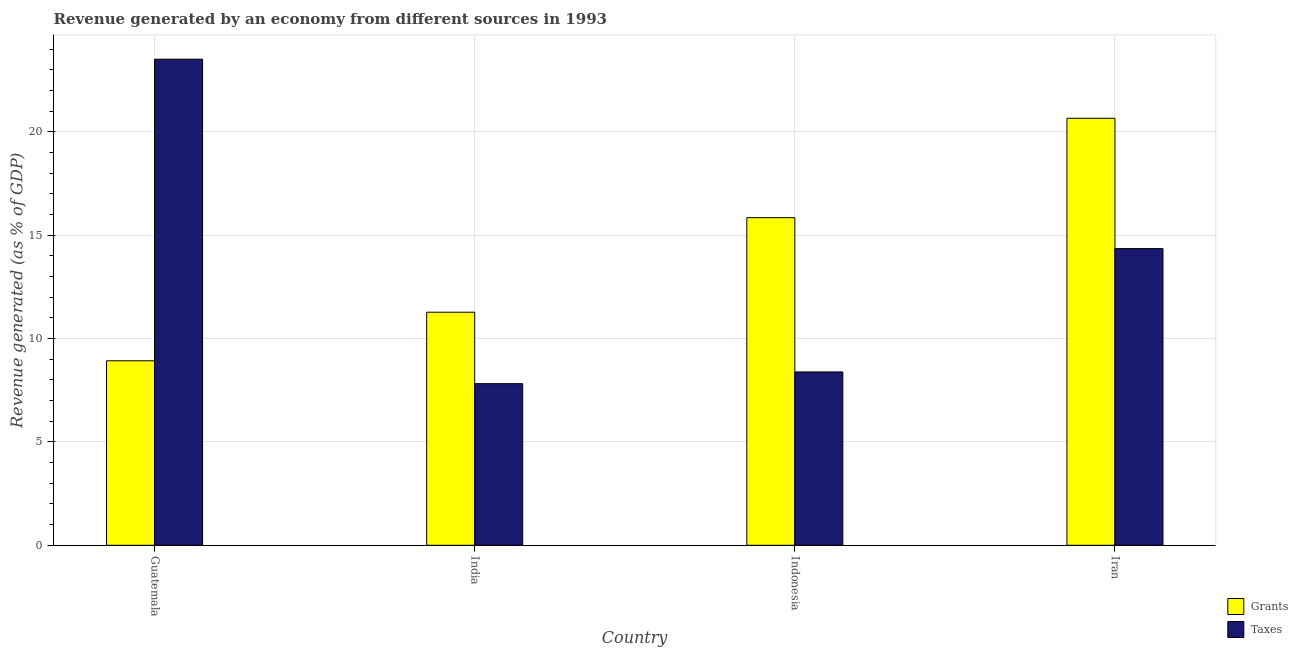How many groups of bars are there?
Offer a terse response. 4. Are the number of bars per tick equal to the number of legend labels?
Give a very brief answer. Yes. Are the number of bars on each tick of the X-axis equal?
Your answer should be very brief. Yes. How many bars are there on the 1st tick from the left?
Provide a short and direct response. 2. How many bars are there on the 4th tick from the right?
Ensure brevity in your answer.  2. What is the revenue generated by taxes in Guatemala?
Provide a short and direct response. 23.52. Across all countries, what is the maximum revenue generated by taxes?
Keep it short and to the point. 23.52. Across all countries, what is the minimum revenue generated by taxes?
Offer a very short reply. 7.82. In which country was the revenue generated by taxes maximum?
Your response must be concise. Guatemala. In which country was the revenue generated by grants minimum?
Give a very brief answer. Guatemala. What is the total revenue generated by taxes in the graph?
Make the answer very short. 54.09. What is the difference between the revenue generated by taxes in India and that in Indonesia?
Give a very brief answer. -0.57. What is the difference between the revenue generated by grants in Iran and the revenue generated by taxes in Guatemala?
Provide a succinct answer. -2.86. What is the average revenue generated by grants per country?
Your answer should be compact. 14.18. What is the difference between the revenue generated by grants and revenue generated by taxes in Iran?
Provide a short and direct response. 6.31. In how many countries, is the revenue generated by taxes greater than 9 %?
Offer a very short reply. 2. What is the ratio of the revenue generated by grants in Guatemala to that in India?
Ensure brevity in your answer.  0.79. Is the difference between the revenue generated by taxes in India and Iran greater than the difference between the revenue generated by grants in India and Iran?
Make the answer very short. Yes. What is the difference between the highest and the second highest revenue generated by grants?
Your response must be concise. 4.81. What is the difference between the highest and the lowest revenue generated by taxes?
Your response must be concise. 15.7. In how many countries, is the revenue generated by taxes greater than the average revenue generated by taxes taken over all countries?
Your answer should be compact. 2. Is the sum of the revenue generated by grants in India and Iran greater than the maximum revenue generated by taxes across all countries?
Your answer should be compact. Yes. What does the 2nd bar from the left in Iran represents?
Keep it short and to the point. Taxes. What does the 2nd bar from the right in Guatemala represents?
Make the answer very short. Grants. How many bars are there?
Provide a short and direct response. 8. Are the values on the major ticks of Y-axis written in scientific E-notation?
Give a very brief answer. No. Does the graph contain any zero values?
Your response must be concise. No. What is the title of the graph?
Give a very brief answer. Revenue generated by an economy from different sources in 1993. What is the label or title of the X-axis?
Your answer should be very brief. Country. What is the label or title of the Y-axis?
Your response must be concise. Revenue generated (as % of GDP). What is the Revenue generated (as % of GDP) of Grants in Guatemala?
Ensure brevity in your answer.  8.93. What is the Revenue generated (as % of GDP) in Taxes in Guatemala?
Your answer should be compact. 23.52. What is the Revenue generated (as % of GDP) in Grants in India?
Your answer should be very brief. 11.28. What is the Revenue generated (as % of GDP) in Taxes in India?
Keep it short and to the point. 7.82. What is the Revenue generated (as % of GDP) of Grants in Indonesia?
Provide a succinct answer. 15.85. What is the Revenue generated (as % of GDP) in Taxes in Indonesia?
Offer a terse response. 8.39. What is the Revenue generated (as % of GDP) in Grants in Iran?
Your answer should be compact. 20.66. What is the Revenue generated (as % of GDP) in Taxes in Iran?
Your answer should be very brief. 14.36. Across all countries, what is the maximum Revenue generated (as % of GDP) in Grants?
Your answer should be very brief. 20.66. Across all countries, what is the maximum Revenue generated (as % of GDP) of Taxes?
Ensure brevity in your answer.  23.52. Across all countries, what is the minimum Revenue generated (as % of GDP) in Grants?
Your response must be concise. 8.93. Across all countries, what is the minimum Revenue generated (as % of GDP) of Taxes?
Ensure brevity in your answer.  7.82. What is the total Revenue generated (as % of GDP) in Grants in the graph?
Provide a short and direct response. 56.72. What is the total Revenue generated (as % of GDP) in Taxes in the graph?
Your answer should be very brief. 54.09. What is the difference between the Revenue generated (as % of GDP) in Grants in Guatemala and that in India?
Your answer should be compact. -2.35. What is the difference between the Revenue generated (as % of GDP) of Taxes in Guatemala and that in India?
Offer a terse response. 15.7. What is the difference between the Revenue generated (as % of GDP) of Grants in Guatemala and that in Indonesia?
Provide a succinct answer. -6.93. What is the difference between the Revenue generated (as % of GDP) in Taxes in Guatemala and that in Indonesia?
Your answer should be compact. 15.13. What is the difference between the Revenue generated (as % of GDP) of Grants in Guatemala and that in Iran?
Your answer should be compact. -11.73. What is the difference between the Revenue generated (as % of GDP) in Taxes in Guatemala and that in Iran?
Make the answer very short. 9.17. What is the difference between the Revenue generated (as % of GDP) of Grants in India and that in Indonesia?
Offer a very short reply. -4.58. What is the difference between the Revenue generated (as % of GDP) in Taxes in India and that in Indonesia?
Your answer should be compact. -0.57. What is the difference between the Revenue generated (as % of GDP) in Grants in India and that in Iran?
Provide a succinct answer. -9.38. What is the difference between the Revenue generated (as % of GDP) of Taxes in India and that in Iran?
Your answer should be very brief. -6.54. What is the difference between the Revenue generated (as % of GDP) in Grants in Indonesia and that in Iran?
Your answer should be very brief. -4.81. What is the difference between the Revenue generated (as % of GDP) in Taxes in Indonesia and that in Iran?
Provide a succinct answer. -5.97. What is the difference between the Revenue generated (as % of GDP) of Grants in Guatemala and the Revenue generated (as % of GDP) of Taxes in India?
Your answer should be compact. 1.11. What is the difference between the Revenue generated (as % of GDP) of Grants in Guatemala and the Revenue generated (as % of GDP) of Taxes in Indonesia?
Offer a terse response. 0.54. What is the difference between the Revenue generated (as % of GDP) of Grants in Guatemala and the Revenue generated (as % of GDP) of Taxes in Iran?
Offer a terse response. -5.43. What is the difference between the Revenue generated (as % of GDP) in Grants in India and the Revenue generated (as % of GDP) in Taxes in Indonesia?
Your answer should be very brief. 2.89. What is the difference between the Revenue generated (as % of GDP) in Grants in India and the Revenue generated (as % of GDP) in Taxes in Iran?
Make the answer very short. -3.08. What is the difference between the Revenue generated (as % of GDP) of Grants in Indonesia and the Revenue generated (as % of GDP) of Taxes in Iran?
Your response must be concise. 1.5. What is the average Revenue generated (as % of GDP) of Grants per country?
Your answer should be very brief. 14.18. What is the average Revenue generated (as % of GDP) in Taxes per country?
Provide a short and direct response. 13.52. What is the difference between the Revenue generated (as % of GDP) in Grants and Revenue generated (as % of GDP) in Taxes in Guatemala?
Your answer should be very brief. -14.59. What is the difference between the Revenue generated (as % of GDP) of Grants and Revenue generated (as % of GDP) of Taxes in India?
Your response must be concise. 3.46. What is the difference between the Revenue generated (as % of GDP) of Grants and Revenue generated (as % of GDP) of Taxes in Indonesia?
Offer a very short reply. 7.46. What is the difference between the Revenue generated (as % of GDP) of Grants and Revenue generated (as % of GDP) of Taxes in Iran?
Provide a short and direct response. 6.31. What is the ratio of the Revenue generated (as % of GDP) in Grants in Guatemala to that in India?
Your answer should be compact. 0.79. What is the ratio of the Revenue generated (as % of GDP) in Taxes in Guatemala to that in India?
Your answer should be very brief. 3.01. What is the ratio of the Revenue generated (as % of GDP) in Grants in Guatemala to that in Indonesia?
Your answer should be compact. 0.56. What is the ratio of the Revenue generated (as % of GDP) of Taxes in Guatemala to that in Indonesia?
Ensure brevity in your answer.  2.8. What is the ratio of the Revenue generated (as % of GDP) of Grants in Guatemala to that in Iran?
Ensure brevity in your answer.  0.43. What is the ratio of the Revenue generated (as % of GDP) in Taxes in Guatemala to that in Iran?
Your response must be concise. 1.64. What is the ratio of the Revenue generated (as % of GDP) of Grants in India to that in Indonesia?
Offer a very short reply. 0.71. What is the ratio of the Revenue generated (as % of GDP) of Taxes in India to that in Indonesia?
Provide a short and direct response. 0.93. What is the ratio of the Revenue generated (as % of GDP) in Grants in India to that in Iran?
Keep it short and to the point. 0.55. What is the ratio of the Revenue generated (as % of GDP) in Taxes in India to that in Iran?
Ensure brevity in your answer.  0.54. What is the ratio of the Revenue generated (as % of GDP) of Grants in Indonesia to that in Iran?
Give a very brief answer. 0.77. What is the ratio of the Revenue generated (as % of GDP) of Taxes in Indonesia to that in Iran?
Make the answer very short. 0.58. What is the difference between the highest and the second highest Revenue generated (as % of GDP) of Grants?
Ensure brevity in your answer.  4.81. What is the difference between the highest and the second highest Revenue generated (as % of GDP) in Taxes?
Provide a succinct answer. 9.17. What is the difference between the highest and the lowest Revenue generated (as % of GDP) in Grants?
Ensure brevity in your answer.  11.73. What is the difference between the highest and the lowest Revenue generated (as % of GDP) of Taxes?
Offer a terse response. 15.7. 